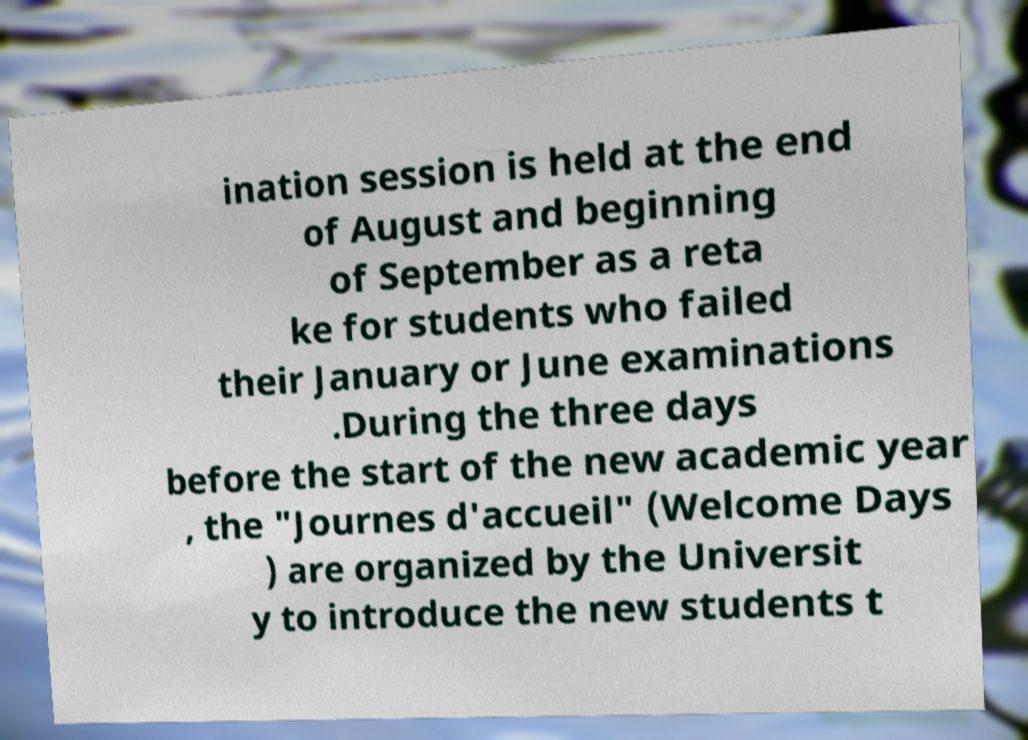There's text embedded in this image that I need extracted. Can you transcribe it verbatim? ination session is held at the end of August and beginning of September as a reta ke for students who failed their January or June examinations .During the three days before the start of the new academic year , the "Journes d'accueil" (Welcome Days ) are organized by the Universit y to introduce the new students t 